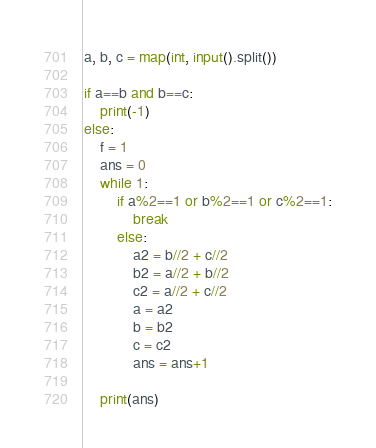<code> <loc_0><loc_0><loc_500><loc_500><_Python_>a, b, c = map(int, input().split())

if a==b and b==c:
    print(-1)
else:
    f = 1
    ans = 0
    while 1:
        if a%2==1 or b%2==1 or c%2==1:
            break
        else:
            a2 = b//2 + c//2
            b2 = a//2 + b//2
            c2 = a//2 + c//2
            a = a2
            b = b2
            c = c2
            ans = ans+1
        
    print(ans)</code> 